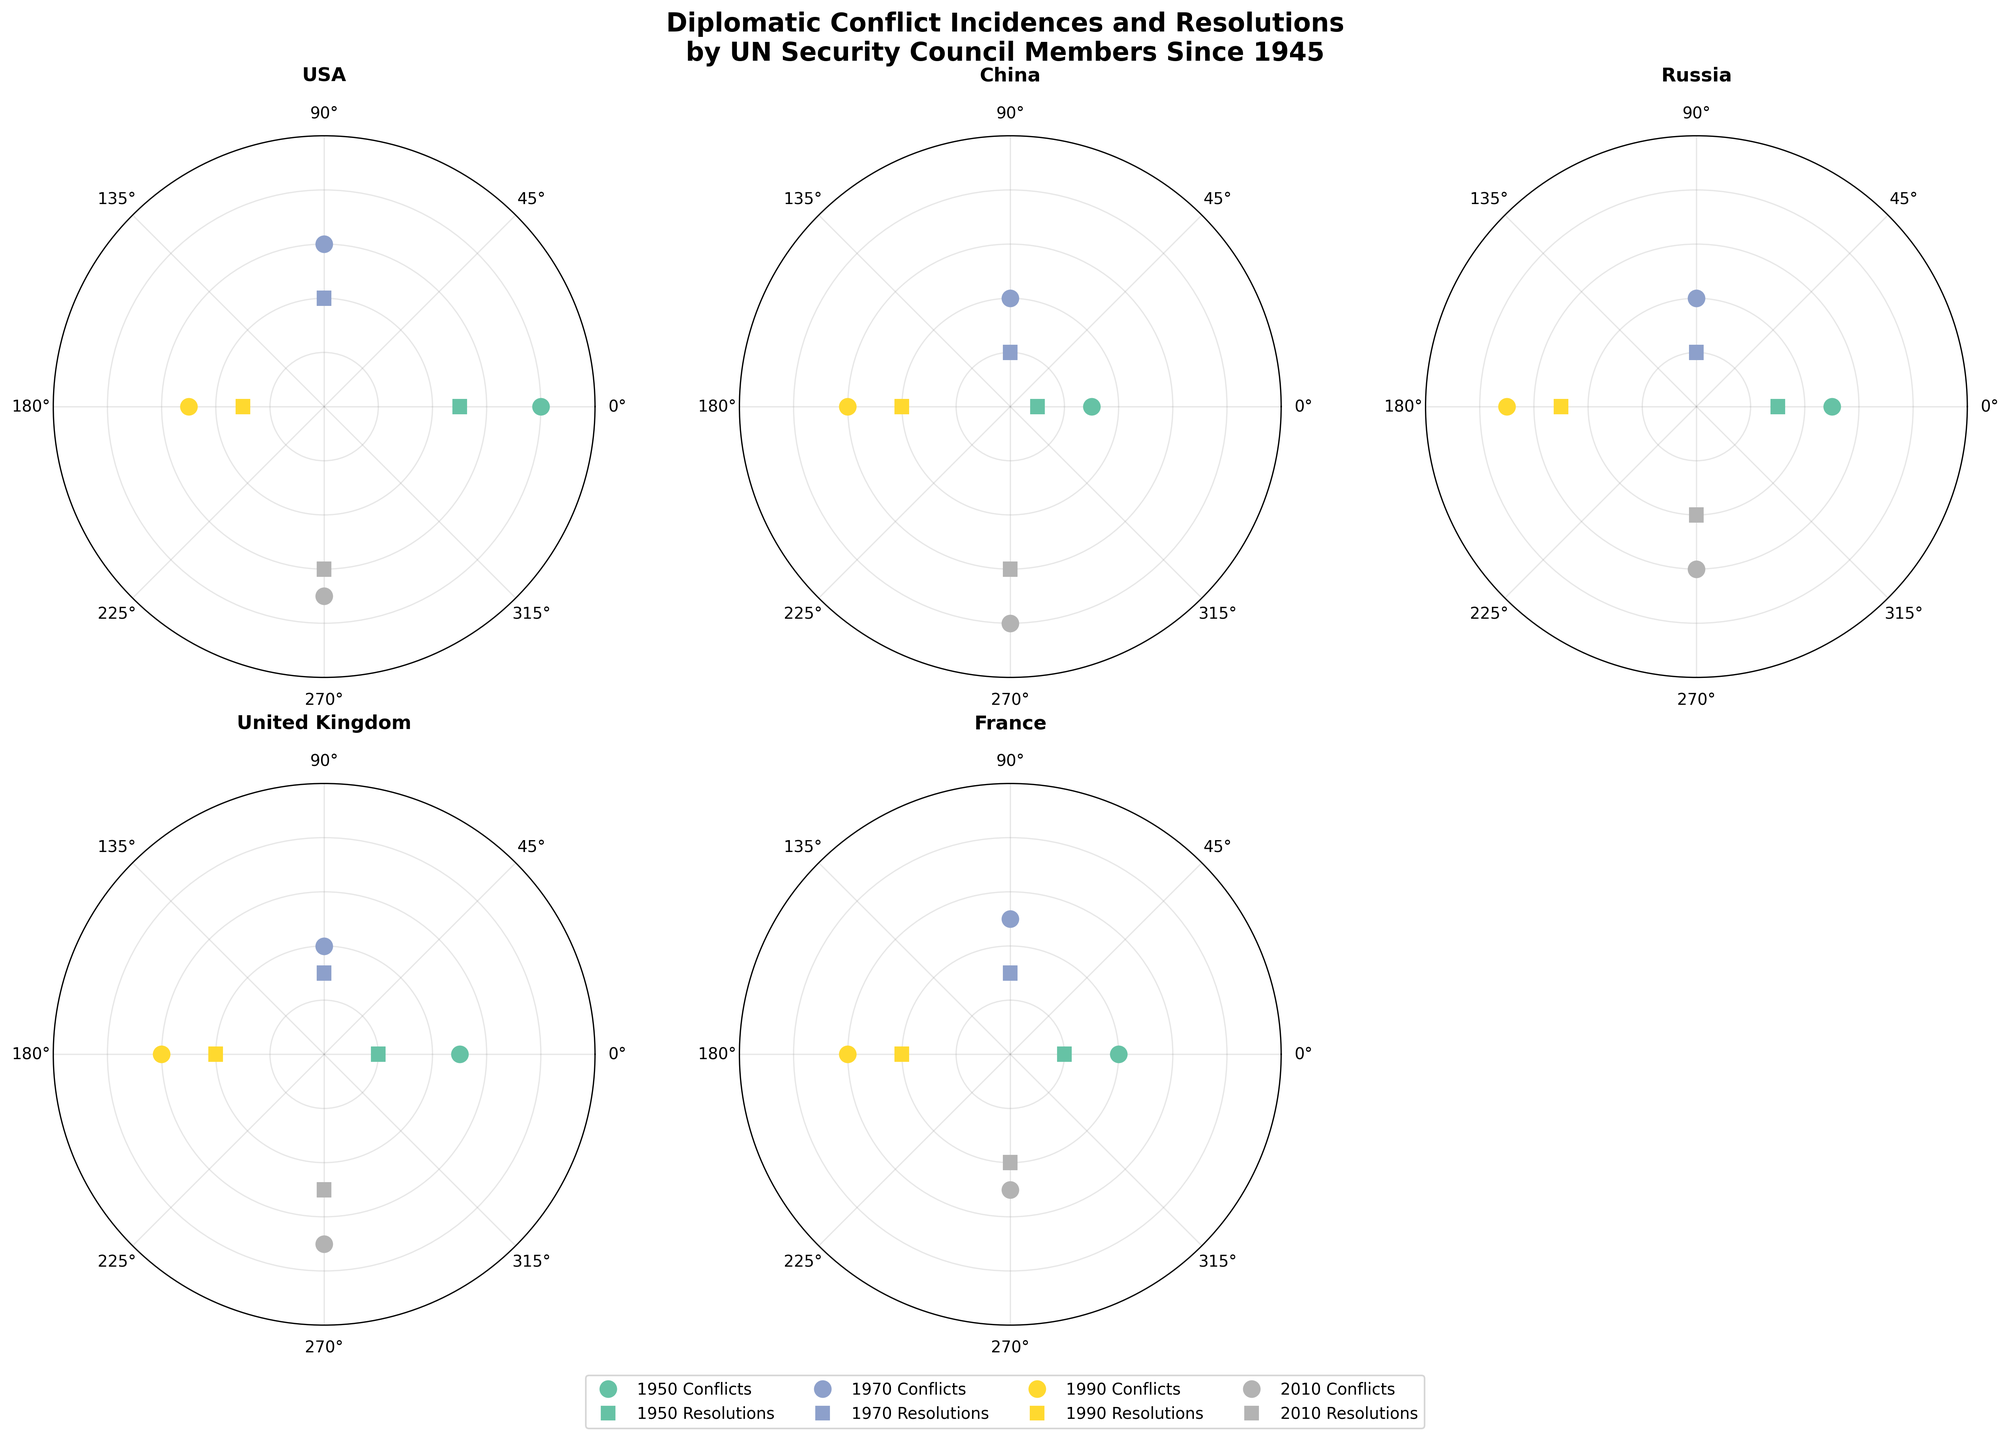What is the total number of conflict incidences for the USA in 1950? By looking at the plot for the USA in 1950, we observe a data point indicating 8 conflict incidences.
Answer: 8 How many resolutions by the UN Security Council were there for China in 1990? The polar chart for China in 1990 shows a data point representing 4 resolutions by the UN Security Council.
Answer: 4 Which country had the highest number of conflict incidences in 2010? In 2010, China had the highest number of conflict incidences, indicated by the outermost data point compared to other countries.
Answer: China Compare the resolutions by the UN Security Council for Russia between 1950 and 1990. Which year had more resolutions? By examining the data points for Russia, 1990 had more resolutions (5) by the UN Security Council compared to 1950 (3).
Answer: 1990 What is the overall trend for the United Kingdom's conflict incidences from 1950 to 2010? For the United Kingdom, the conflict incidences data points are 5 in 1950, 4 in 1970, 6 in 1990, and 7 in 2010. This shows a slight increase over the decades, with some fluctuations.
Answer: Increasing Which country has the least fluctuation in conflict incidences over the years? By analyzing all the subplots, France appears to have the least fluctuation, with conflict incidences close to 4-6 over all years.
Answer: France What are the total resolutions by the UN Security Council for all years for France? Adding the data points for France's resolutions: 2 (1950) + 3 (1970) + 4 (1990) + 4 (2010) = 13 resolutions.
Answer: 13 